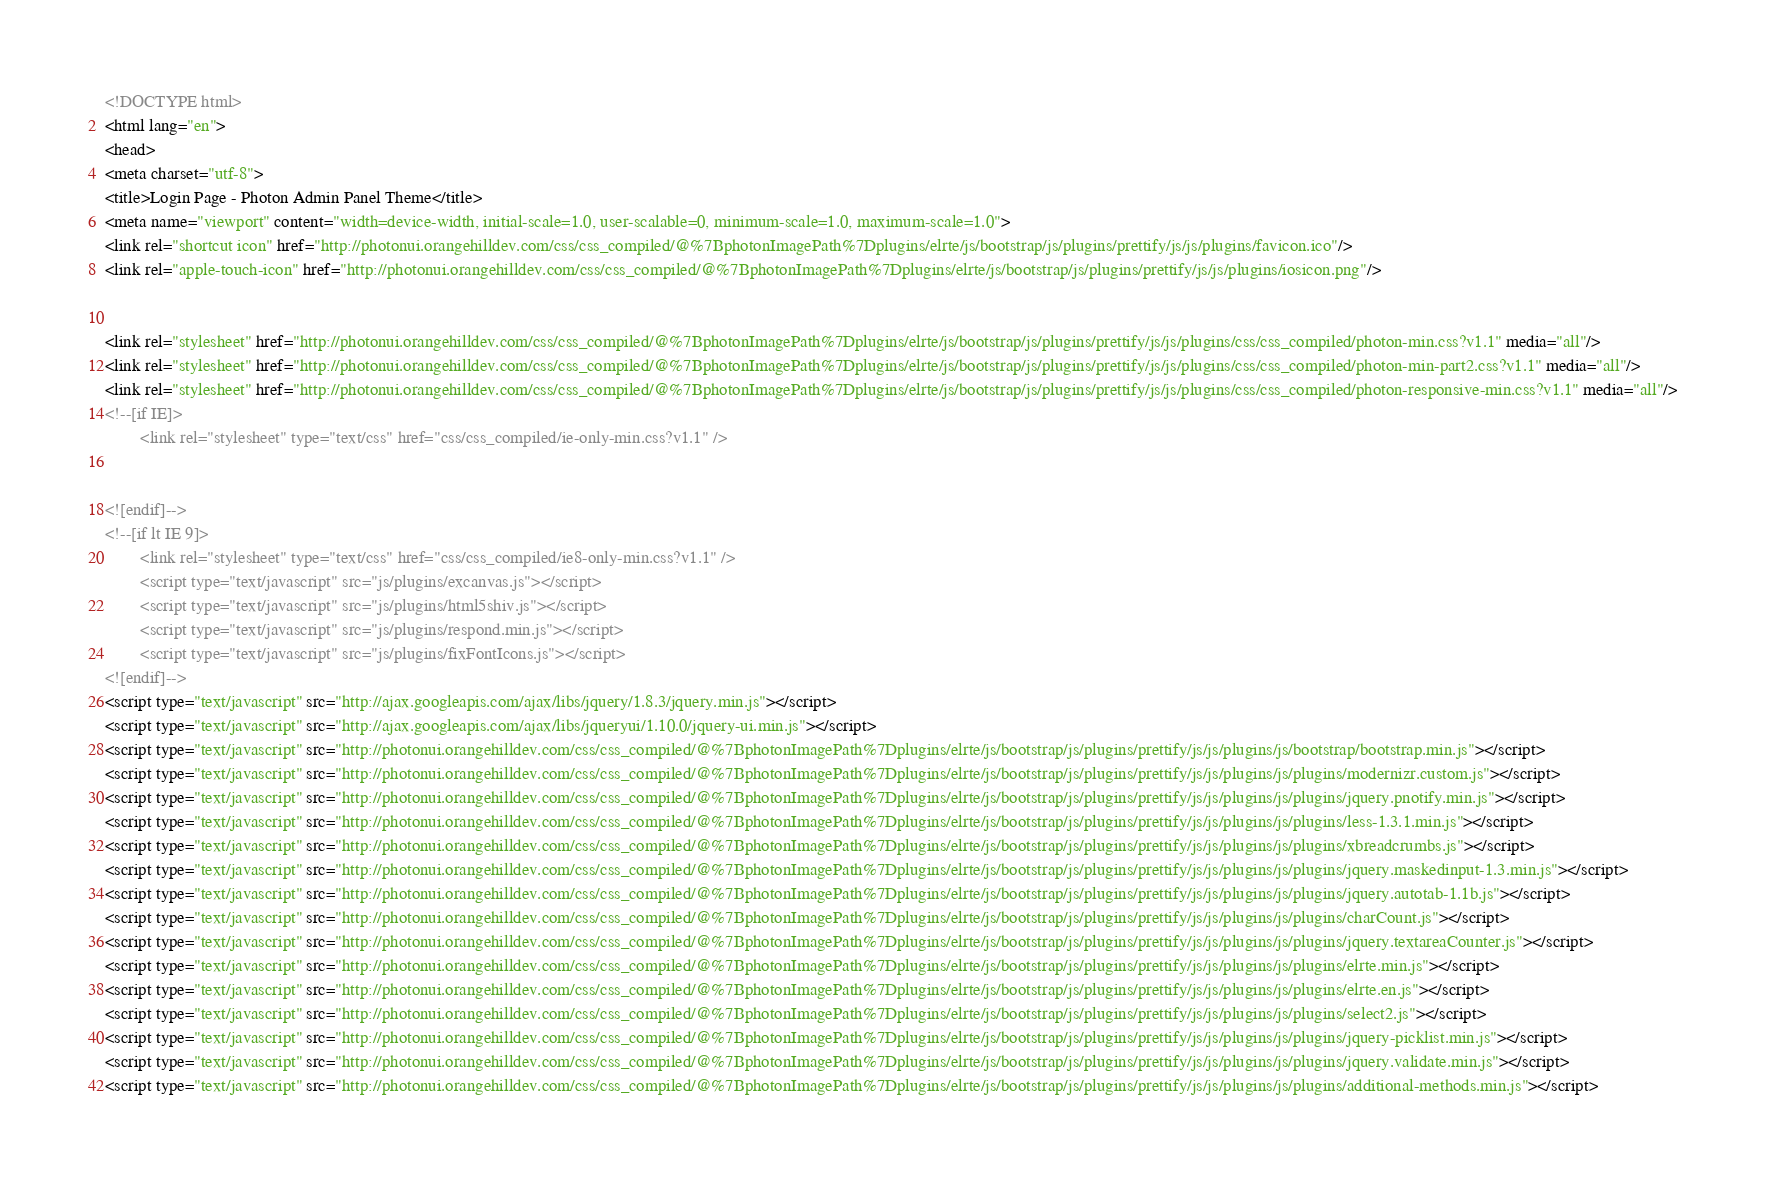<code> <loc_0><loc_0><loc_500><loc_500><_HTML_><!DOCTYPE html>
<html lang="en">
<head>
<meta charset="utf-8">
<title>Login Page - Photon Admin Panel Theme</title>
<meta name="viewport" content="width=device-width, initial-scale=1.0, user-scalable=0, minimum-scale=1.0, maximum-scale=1.0">
<link rel="shortcut icon" href="http://photonui.orangehilldev.com/css/css_compiled/@%7BphotonImagePath%7Dplugins/elrte/js/bootstrap/js/plugins/prettify/js/js/plugins/favicon.ico"/>
<link rel="apple-touch-icon" href="http://photonui.orangehilldev.com/css/css_compiled/@%7BphotonImagePath%7Dplugins/elrte/js/bootstrap/js/plugins/prettify/js/js/plugins/iosicon.png"/>
 
   
<link rel="stylesheet" href="http://photonui.orangehilldev.com/css/css_compiled/@%7BphotonImagePath%7Dplugins/elrte/js/bootstrap/js/plugins/prettify/js/js/plugins/css/css_compiled/photon-min.css?v1.1" media="all"/>
<link rel="stylesheet" href="http://photonui.orangehilldev.com/css/css_compiled/@%7BphotonImagePath%7Dplugins/elrte/js/bootstrap/js/plugins/prettify/js/js/plugins/css/css_compiled/photon-min-part2.css?v1.1" media="all"/>
<link rel="stylesheet" href="http://photonui.orangehilldev.com/css/css_compiled/@%7BphotonImagePath%7Dplugins/elrte/js/bootstrap/js/plugins/prettify/js/js/plugins/css/css_compiled/photon-responsive-min.css?v1.1" media="all"/>
<!--[if IE]>
        <link rel="stylesheet" type="text/css" href="css/css_compiled/ie-only-min.css?v1.1" />
        

<![endif]-->
<!--[if lt IE 9]>
        <link rel="stylesheet" type="text/css" href="css/css_compiled/ie8-only-min.css?v1.1" />
        <script type="text/javascript" src="js/plugins/excanvas.js"></script>
        <script type="text/javascript" src="js/plugins/html5shiv.js"></script>
        <script type="text/javascript" src="js/plugins/respond.min.js"></script>
        <script type="text/javascript" src="js/plugins/fixFontIcons.js"></script>
<![endif]-->
<script type="text/javascript" src="http://ajax.googleapis.com/ajax/libs/jquery/1.8.3/jquery.min.js"></script>
<script type="text/javascript" src="http://ajax.googleapis.com/ajax/libs/jqueryui/1.10.0/jquery-ui.min.js"></script>
<script type="text/javascript" src="http://photonui.orangehilldev.com/css/css_compiled/@%7BphotonImagePath%7Dplugins/elrte/js/bootstrap/js/plugins/prettify/js/js/plugins/js/bootstrap/bootstrap.min.js"></script>
<script type="text/javascript" src="http://photonui.orangehilldev.com/css/css_compiled/@%7BphotonImagePath%7Dplugins/elrte/js/bootstrap/js/plugins/prettify/js/js/plugins/js/plugins/modernizr.custom.js"></script>
<script type="text/javascript" src="http://photonui.orangehilldev.com/css/css_compiled/@%7BphotonImagePath%7Dplugins/elrte/js/bootstrap/js/plugins/prettify/js/js/plugins/js/plugins/jquery.pnotify.min.js"></script>
<script type="text/javascript" src="http://photonui.orangehilldev.com/css/css_compiled/@%7BphotonImagePath%7Dplugins/elrte/js/bootstrap/js/plugins/prettify/js/js/plugins/js/plugins/less-1.3.1.min.js"></script>
<script type="text/javascript" src="http://photonui.orangehilldev.com/css/css_compiled/@%7BphotonImagePath%7Dplugins/elrte/js/bootstrap/js/plugins/prettify/js/js/plugins/js/plugins/xbreadcrumbs.js"></script>
<script type="text/javascript" src="http://photonui.orangehilldev.com/css/css_compiled/@%7BphotonImagePath%7Dplugins/elrte/js/bootstrap/js/plugins/prettify/js/js/plugins/js/plugins/jquery.maskedinput-1.3.min.js"></script>
<script type="text/javascript" src="http://photonui.orangehilldev.com/css/css_compiled/@%7BphotonImagePath%7Dplugins/elrte/js/bootstrap/js/plugins/prettify/js/js/plugins/js/plugins/jquery.autotab-1.1b.js"></script>
<script type="text/javascript" src="http://photonui.orangehilldev.com/css/css_compiled/@%7BphotonImagePath%7Dplugins/elrte/js/bootstrap/js/plugins/prettify/js/js/plugins/js/plugins/charCount.js"></script>
<script type="text/javascript" src="http://photonui.orangehilldev.com/css/css_compiled/@%7BphotonImagePath%7Dplugins/elrte/js/bootstrap/js/plugins/prettify/js/js/plugins/js/plugins/jquery.textareaCounter.js"></script>
<script type="text/javascript" src="http://photonui.orangehilldev.com/css/css_compiled/@%7BphotonImagePath%7Dplugins/elrte/js/bootstrap/js/plugins/prettify/js/js/plugins/js/plugins/elrte.min.js"></script>
<script type="text/javascript" src="http://photonui.orangehilldev.com/css/css_compiled/@%7BphotonImagePath%7Dplugins/elrte/js/bootstrap/js/plugins/prettify/js/js/plugins/js/plugins/elrte.en.js"></script>
<script type="text/javascript" src="http://photonui.orangehilldev.com/css/css_compiled/@%7BphotonImagePath%7Dplugins/elrte/js/bootstrap/js/plugins/prettify/js/js/plugins/js/plugins/select2.js"></script>
<script type="text/javascript" src="http://photonui.orangehilldev.com/css/css_compiled/@%7BphotonImagePath%7Dplugins/elrte/js/bootstrap/js/plugins/prettify/js/js/plugins/js/plugins/jquery-picklist.min.js"></script>
<script type="text/javascript" src="http://photonui.orangehilldev.com/css/css_compiled/@%7BphotonImagePath%7Dplugins/elrte/js/bootstrap/js/plugins/prettify/js/js/plugins/js/plugins/jquery.validate.min.js"></script>
<script type="text/javascript" src="http://photonui.orangehilldev.com/css/css_compiled/@%7BphotonImagePath%7Dplugins/elrte/js/bootstrap/js/plugins/prettify/js/js/plugins/js/plugins/additional-methods.min.js"></script></code> 